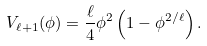<formula> <loc_0><loc_0><loc_500><loc_500>V _ { \ell + 1 } ( \phi ) = \frac { \ell } { 4 } \phi ^ { 2 } \left ( 1 - \phi ^ { 2 / \ell } \right ) .</formula> 